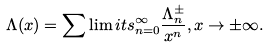<formula> <loc_0><loc_0><loc_500><loc_500>\Lambda ( x ) = \sum \lim i t s _ { n = 0 } ^ { \infty } \frac { \Lambda ^ { \pm } _ { n } } { x ^ { n } } , x \to \pm \infty .</formula> 